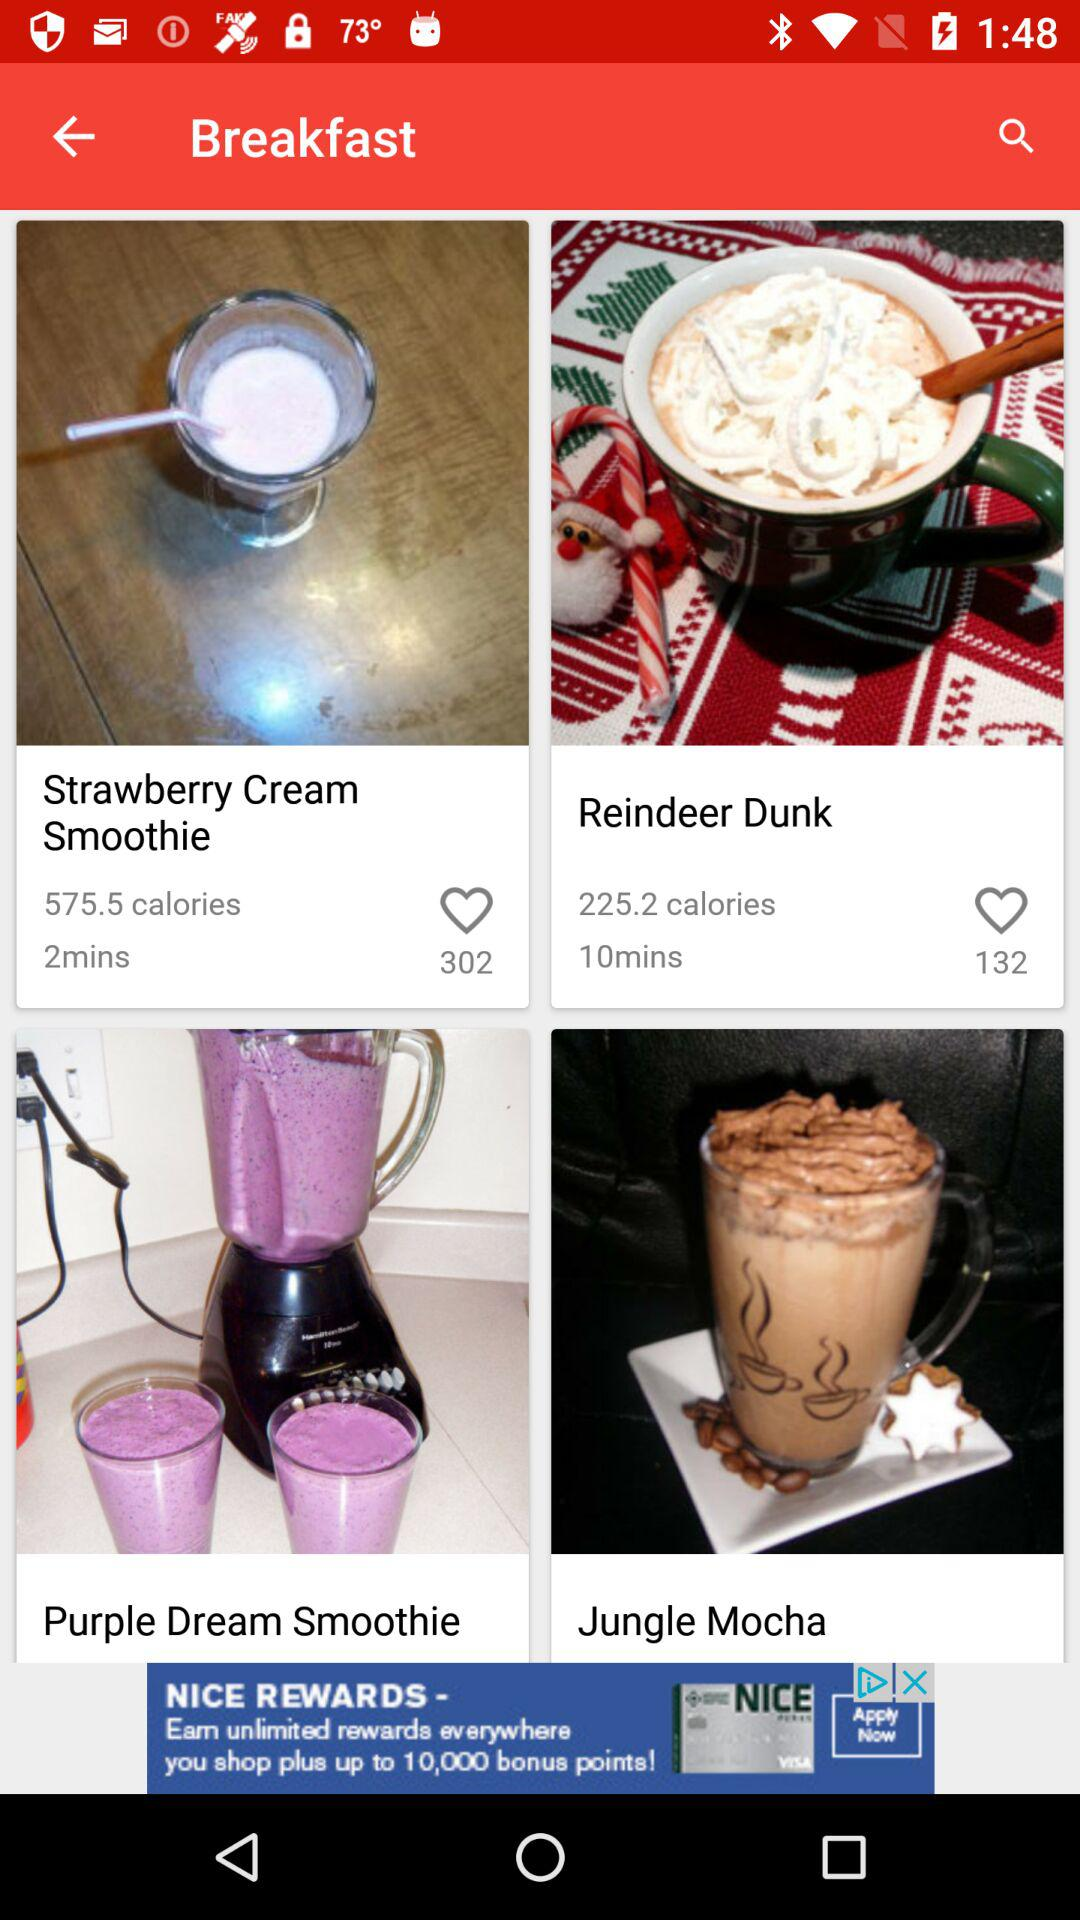How many people have liked strawberry cream smoothie? There are 302 people who liked strawberry cream smoothie. 